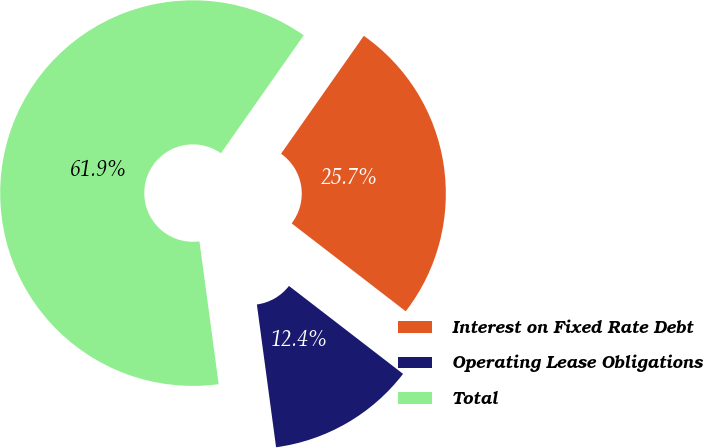Convert chart. <chart><loc_0><loc_0><loc_500><loc_500><pie_chart><fcel>Interest on Fixed Rate Debt<fcel>Operating Lease Obligations<fcel>Total<nl><fcel>25.71%<fcel>12.42%<fcel>61.87%<nl></chart> 